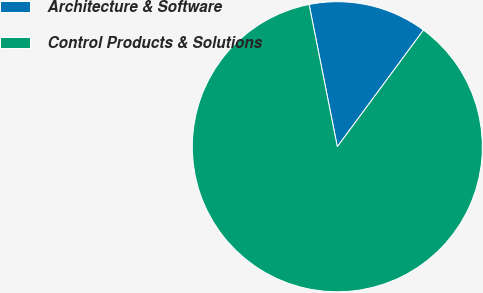<chart> <loc_0><loc_0><loc_500><loc_500><pie_chart><fcel>Architecture & Software<fcel>Control Products & Solutions<nl><fcel>13.24%<fcel>86.76%<nl></chart> 